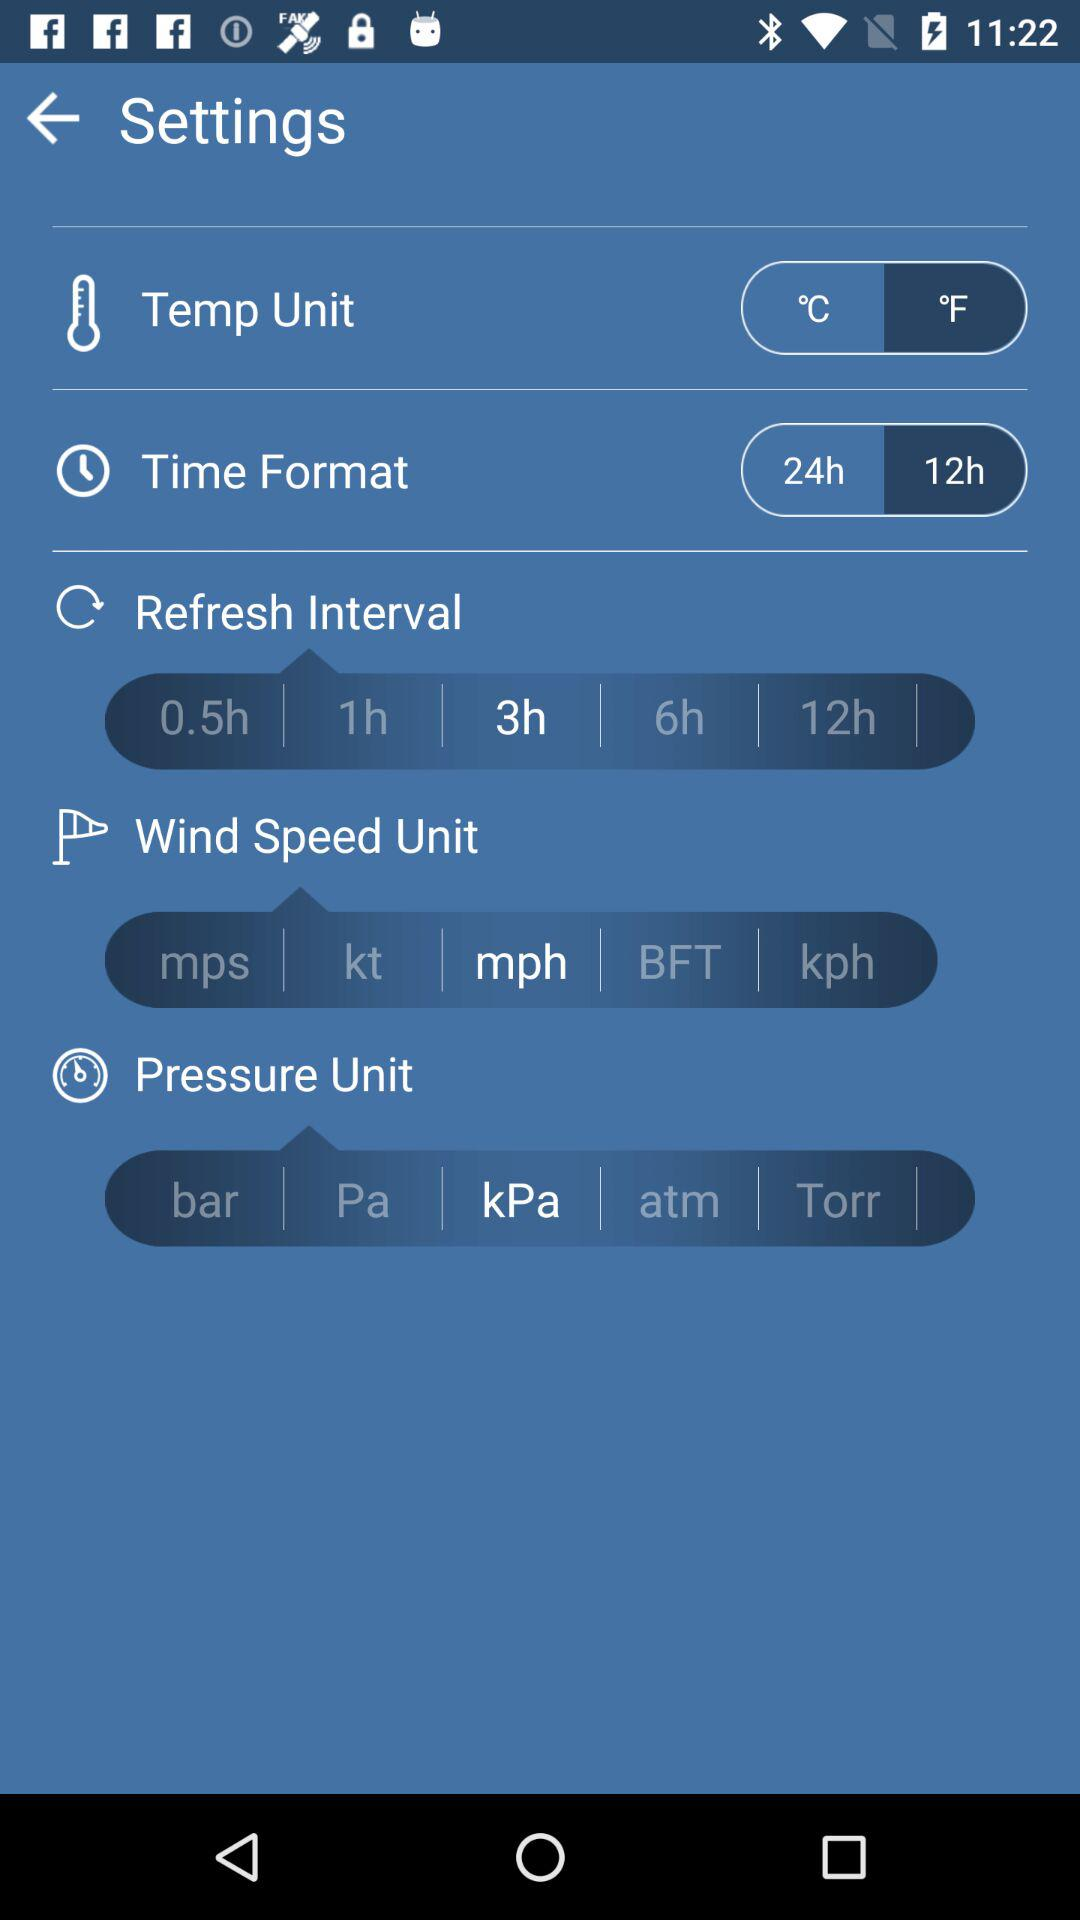What is the selected unit of pressure? The selected unit of pressure is kPa. 